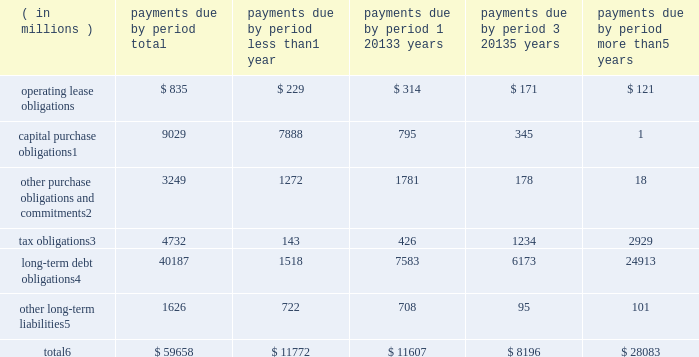Contractual obligations significant contractual obligations as of december 29 , 2018 were as follows: .
Capital purchase obligations1 9029 7888 795 345 1 other purchase obligations and commitments2 3249 1272 1781 178 18 tax obligations3 4732 143 426 1234 2929 long-term debt obligations4 40187 1518 7583 6173 24913 other long-term liabilities5 1626 722 708 95 101 total6 $ 59658 $ 11772 $ 11607 $ 8196 $ 28083 1 capital purchase obligations represent commitments for the construction or purchase of property , plant and equipment .
They were not recorded as liabilities on our consolidated balance sheets as of december 29 , 2018 , as we had not yet received the related goods nor taken title to the property .
2 other purchase obligations and commitments include payments due under various types of licenses and agreements to purchase goods or services , as well as payments due under non-contingent funding obligations .
3 tax obligations represent the future cash payments related to tax reform enacted in 2017 for the one-time transition tax on our previously untaxed foreign earnings .
For further information , see 201cnote 9 : income taxes 201d within the consolidated financial statements .
4 amounts represent principal payments for all debt obligations and interest payments for fixed-rate debt obligations .
Interest payments on floating-rate debt obligations , as well as the impact of fixed-rate to floating-rate debt swaps , are excluded .
Debt obligations are classified based on their stated maturity date , regardless of their classification on the consolidated balance sheets .
Any future settlement of convertible debt would impact our cash payments .
5 amounts represent future cash payments to satisfy other long-term liabilities recorded on our consolidated balance sheets , including the short-term portion of these long-term liabilities .
Derivative instruments are excluded from the preceding table , as they do not represent the amounts that may ultimately be paid .
6 total excludes contractual obligations already recorded on our consolidated balance sheets as current liabilities , except for the short-term portions of long-term debt obligations and other long-term liabilities .
The expected timing of payments of the obligations in the preceding table is estimated based on current information .
Timing of payments and actual amounts paid may be different , depending on the time of receipt of goods or services , or changes to agreed- upon amounts for some obligations .
Contractual obligations for purchases of goods or services included in 201cother purchase obligations and commitments 201d in the preceding table include agreements that are enforceable and legally binding and that specify all significant terms , including fixed or minimum quantities to be purchased ; fixed , minimum , or variable price provisions ; and the approximate timing of the transaction .
For obligations with cancellation provisions , the amounts included in the preceding table were limited to the non-cancelable portion of the agreement terms or the minimum cancellation fee .
For the purchase of raw materials , we have entered into certain agreements that specify minimum prices and quantities based on a percentage of the total available market or based on a percentage of our future purchasing requirements .
Due to the uncertainty of the future market and our future purchasing requirements , as well as the non-binding nature of these agreements , obligations under these agreements have been excluded from the preceding table .
Our purchase orders for other products are based on our current manufacturing needs and are fulfilled by our vendors within short time horizons .
In addition , some of our purchase orders represent authorizations to purchase rather than binding agreements .
Contractual obligations that are contingent upon the achievement of certain milestones have been excluded from the preceding table .
Most of our milestone-based contracts are tooling related for the purchase of capital equipment .
These arrangements are not considered contractual obligations until the milestone is met by the counterparty .
As of december 29 , 2018 , assuming that all future milestones are met , the additional required payments would be approximately $ 688 million .
For the majority of restricted stock units ( rsus ) granted , the number of shares of common stock issued on the date the rsus vest is net of the minimum statutory withholding requirements that we pay in cash to the appropriate taxing authorities on behalf of our employees .
The obligation to pay the relevant taxing authority is excluded from the preceding table , as the amount is contingent upon continued employment .
In addition , the amount of the obligation is unknown , as it is based in part on the market price of our common stock when the awards vest .
Md&a consolidated results and analysis 42 .
What percentage of total contractual obligations as of december 29 , 2018 are due to long-term debt obligations? 
Computations: (40187 / 59658)
Answer: 0.67362. 